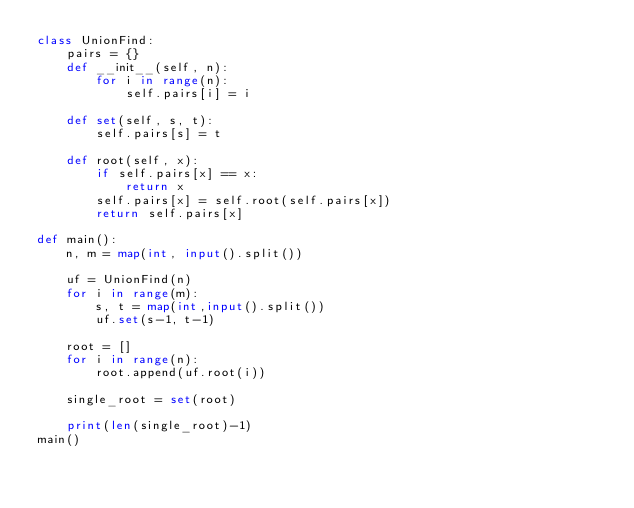<code> <loc_0><loc_0><loc_500><loc_500><_Python_>class UnionFind:
    pairs = {}
    def __init__(self, n):
        for i in range(n):
            self.pairs[i] = i

    def set(self, s, t):
        self.pairs[s] = t

    def root(self, x):
        if self.pairs[x] == x:
            return x
        self.pairs[x] = self.root(self.pairs[x])
        return self.pairs[x]

def main():
    n, m = map(int, input().split())

    uf = UnionFind(n)
    for i in range(m):
        s, t = map(int,input().split())
        uf.set(s-1, t-1)

    root = []
    for i in range(n):
        root.append(uf.root(i))

    single_root = set(root)

    print(len(single_root)-1)
main()</code> 